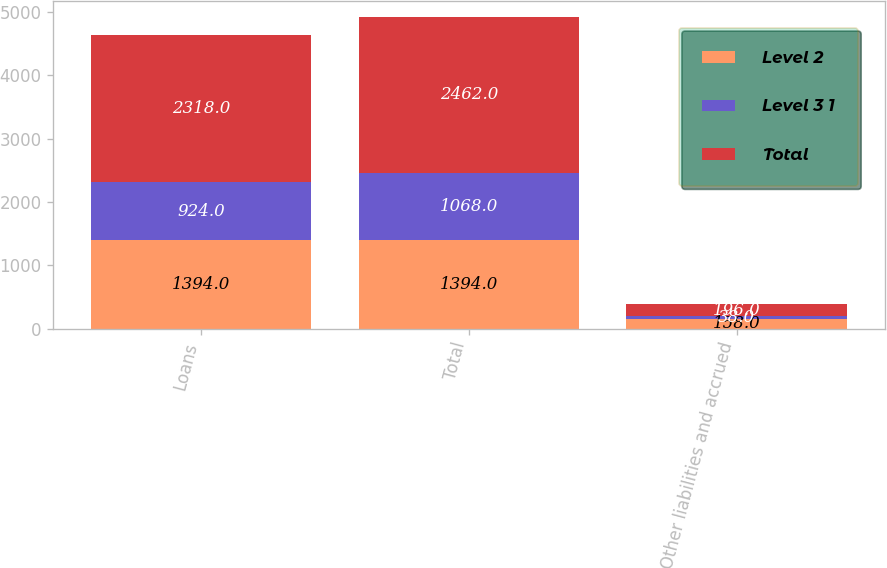<chart> <loc_0><loc_0><loc_500><loc_500><stacked_bar_chart><ecel><fcel>Loans<fcel>Total<fcel>Other liabilities and accrued<nl><fcel>Level 2<fcel>1394<fcel>1394<fcel>158<nl><fcel>Level 3 1<fcel>924<fcel>1068<fcel>38<nl><fcel>Total<fcel>2318<fcel>2462<fcel>196<nl></chart> 